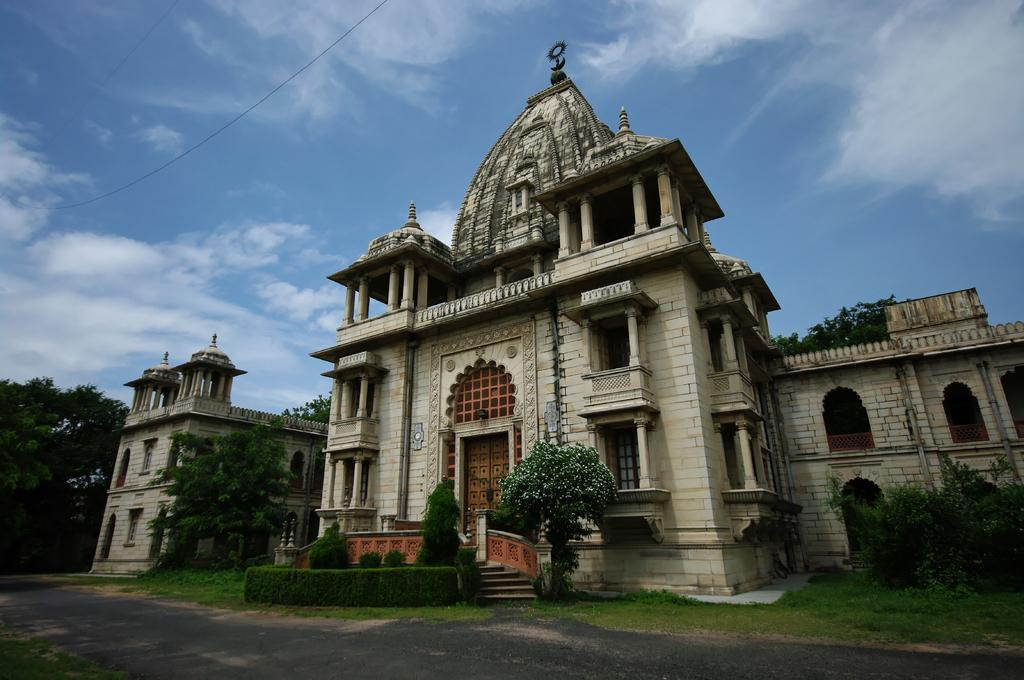What type of structure is present in the image? There is a building in the image. What architectural features can be seen on the building? The building has pillars, windows, and a staircase. What type of vegetation is present in the image? There are plants, grass, and trees in the image. What else can be seen in the image? There is a wire in the image. What is visible in the background of the image? The sky is visible in the image, and it appears cloudy. What type of power does the building generate in the image? There is no information about the building generating power in the image. Can you see any marks on the building in the image? There is no mention of any marks on the building in the image. 